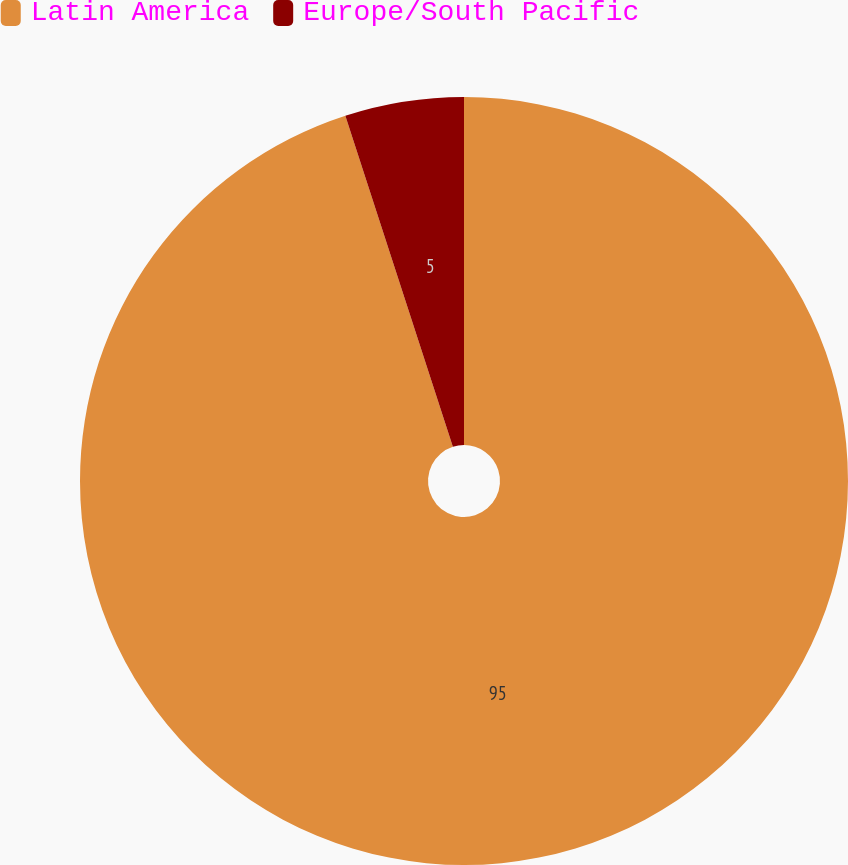Convert chart to OTSL. <chart><loc_0><loc_0><loc_500><loc_500><pie_chart><fcel>Latin America<fcel>Europe/South Pacific<nl><fcel>95.0%<fcel>5.0%<nl></chart> 